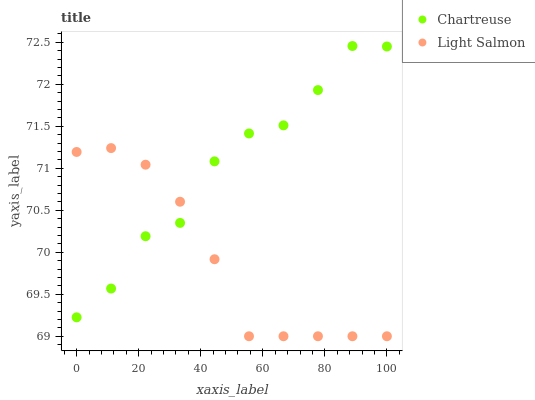Does Light Salmon have the minimum area under the curve?
Answer yes or no. Yes. Does Chartreuse have the maximum area under the curve?
Answer yes or no. Yes. Does Light Salmon have the maximum area under the curve?
Answer yes or no. No. Is Light Salmon the smoothest?
Answer yes or no. Yes. Is Chartreuse the roughest?
Answer yes or no. Yes. Is Light Salmon the roughest?
Answer yes or no. No. Does Light Salmon have the lowest value?
Answer yes or no. Yes. Does Chartreuse have the highest value?
Answer yes or no. Yes. Does Light Salmon have the highest value?
Answer yes or no. No. Does Chartreuse intersect Light Salmon?
Answer yes or no. Yes. Is Chartreuse less than Light Salmon?
Answer yes or no. No. Is Chartreuse greater than Light Salmon?
Answer yes or no. No. 